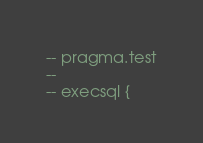<code> <loc_0><loc_0><loc_500><loc_500><_SQL_>-- pragma.test
-- 
-- execsql {</code> 